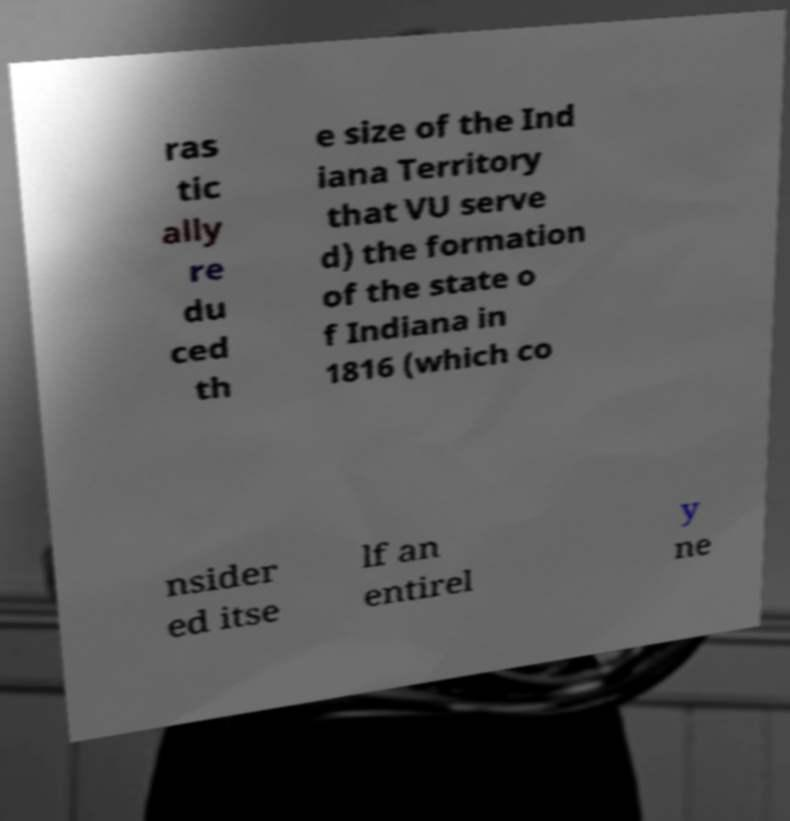Could you extract and type out the text from this image? ras tic ally re du ced th e size of the Ind iana Territory that VU serve d) the formation of the state o f Indiana in 1816 (which co nsider ed itse lf an entirel y ne 